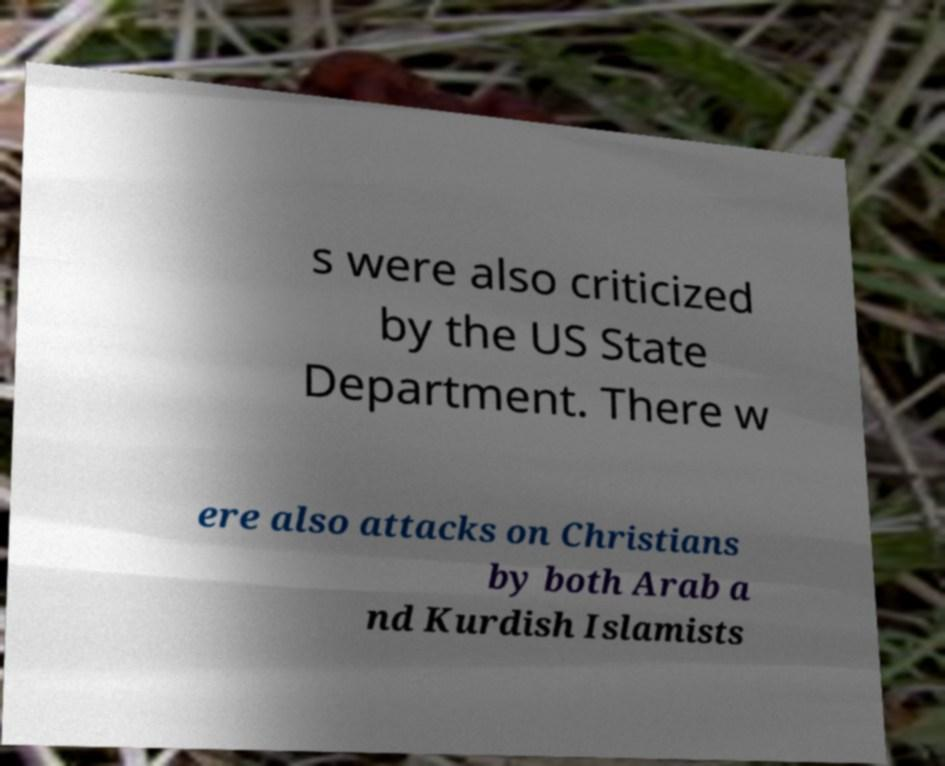Can you accurately transcribe the text from the provided image for me? s were also criticized by the US State Department. There w ere also attacks on Christians by both Arab a nd Kurdish Islamists 